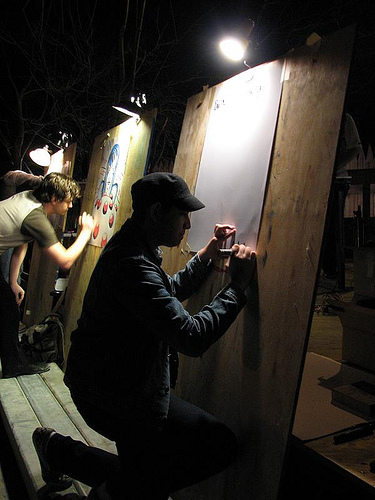<image>
Is the this man in front of the that man? No. The this man is not in front of the that man. The spatial positioning shows a different relationship between these objects. Where is the light in relation to the hat? Is it in front of the hat? No. The light is not in front of the hat. The spatial positioning shows a different relationship between these objects. 